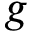Convert formula to latex. <formula><loc_0><loc_0><loc_500><loc_500>g</formula> 